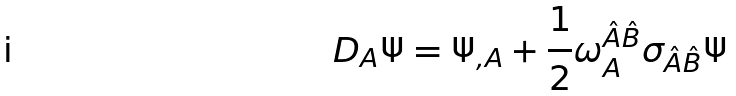<formula> <loc_0><loc_0><loc_500><loc_500>D _ { A } \Psi = \Psi _ { , A } + \frac { 1 } { 2 } \omega ^ { \hat { A } \hat { B } } _ { A } \sigma _ { \hat { A } \hat { B } } \Psi</formula> 